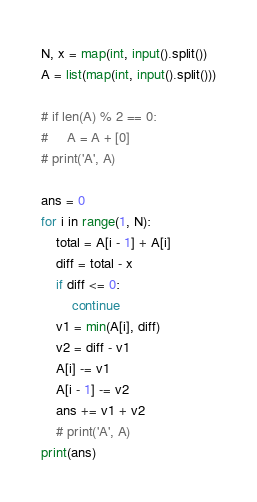<code> <loc_0><loc_0><loc_500><loc_500><_Python_>N, x = map(int, input().split())
A = list(map(int, input().split()))

# if len(A) % 2 == 0:
#     A = A + [0]
# print('A', A)

ans = 0
for i in range(1, N):
    total = A[i - 1] + A[i]
    diff = total - x
    if diff <= 0:
        continue
    v1 = min(A[i], diff)
    v2 = diff - v1
    A[i] -= v1
    A[i - 1] -= v2
    ans += v1 + v2
    # print('A', A)
print(ans)
</code> 